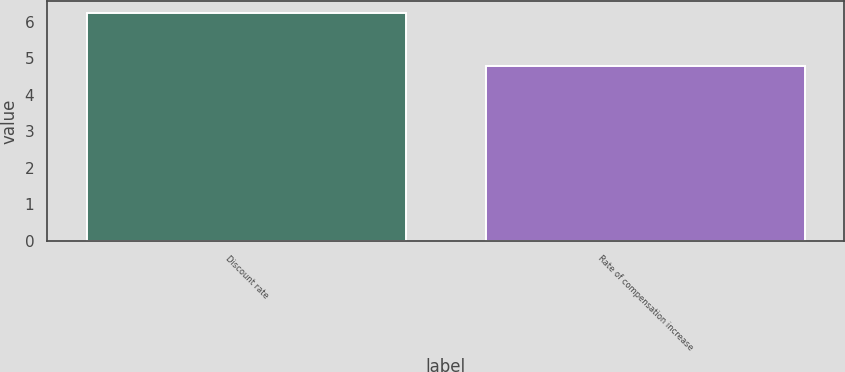<chart> <loc_0><loc_0><loc_500><loc_500><bar_chart><fcel>Discount rate<fcel>Rate of compensation increase<nl><fcel>6.25<fcel>4.8<nl></chart> 